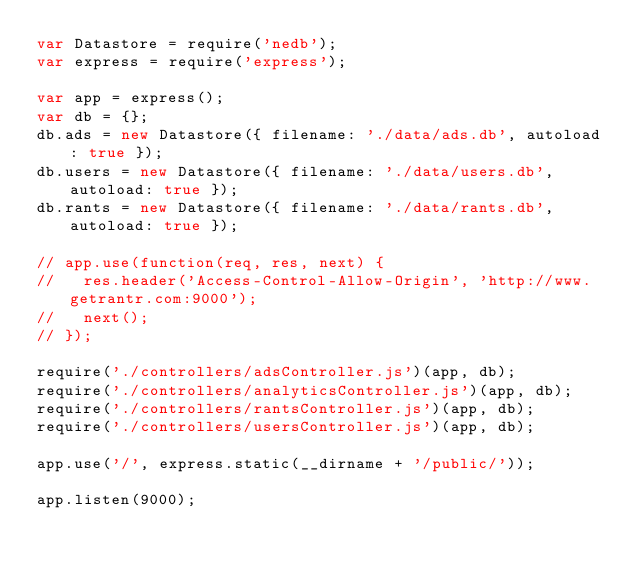Convert code to text. <code><loc_0><loc_0><loc_500><loc_500><_JavaScript_>var Datastore = require('nedb');
var express = require('express');

var app = express();
var db = {};
db.ads = new Datastore({ filename: './data/ads.db', autoload: true });
db.users = new Datastore({ filename: './data/users.db', autoload: true });
db.rants = new Datastore({ filename: './data/rants.db', autoload: true });

// app.use(function(req, res, next) {
//   res.header('Access-Control-Allow-Origin', 'http://www.getrantr.com:9000');
//   next();
// });

require('./controllers/adsController.js')(app, db);
require('./controllers/analyticsController.js')(app, db);
require('./controllers/rantsController.js')(app, db);
require('./controllers/usersController.js')(app, db);

app.use('/', express.static(__dirname + '/public/'));

app.listen(9000);
</code> 